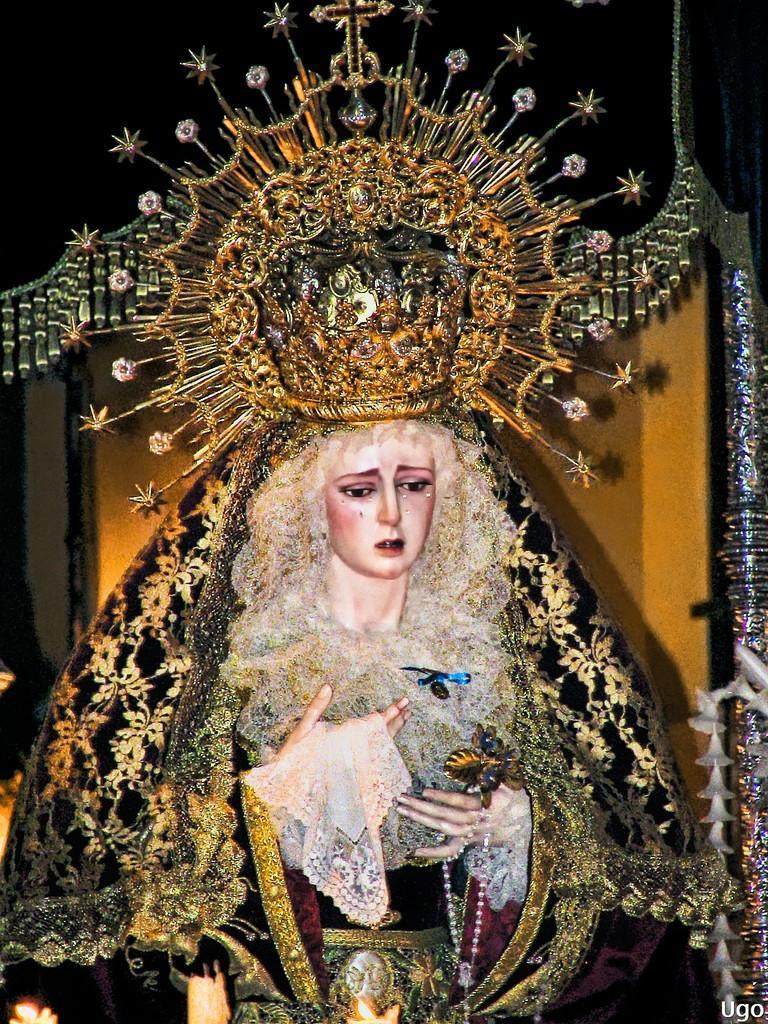Describe this image in one or two sentences. In the picture I can see a painting of a woman. The woman is wearing a crown and clothes. On the bottom right corner I can see a watermark. 